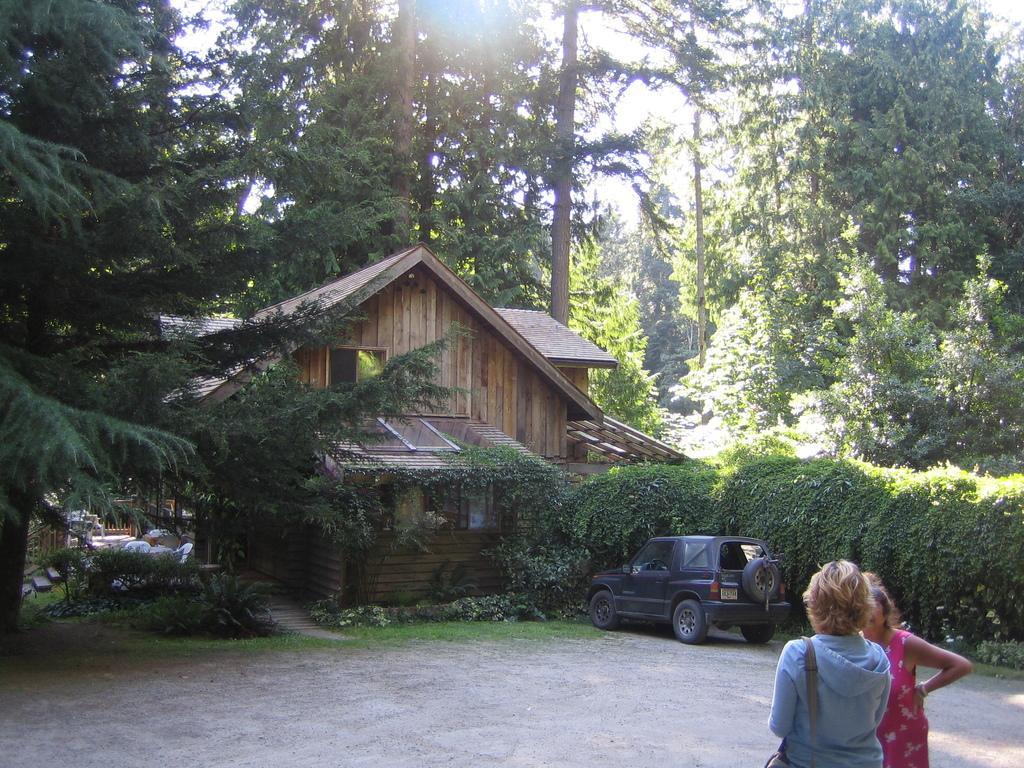How would you summarize this image in a sentence or two? In this image we can see there is a car and there are persons standing on the ground. At the back there are trees, building, chair, stairs and few objects. At the top there is a sky. 